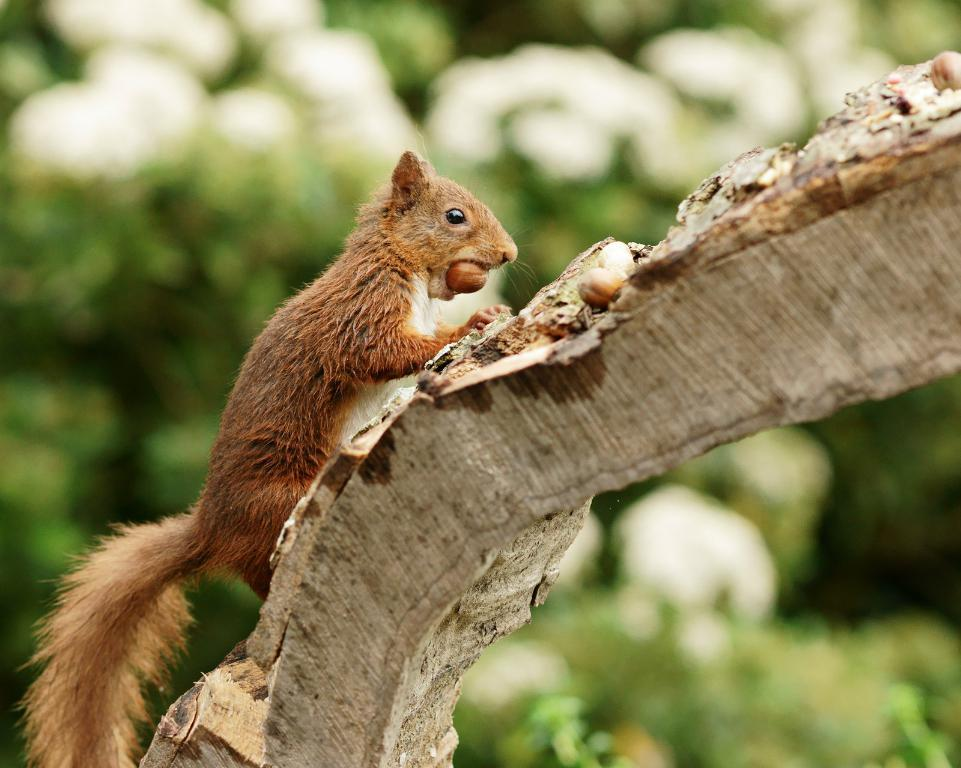What animal is present in the image? There is a squirrel in the image. What is the squirrel standing on? The squirrel is on wood. What is the squirrel holding in its mouth? The squirrel has a nut in its mouth. What type of vegetation can be seen in the image? There are trees visible in the image. What type of quince is being held by the chin of the squirrel in the image? There is no quince present in the image, and the squirrel is not holding anything with its chin. 